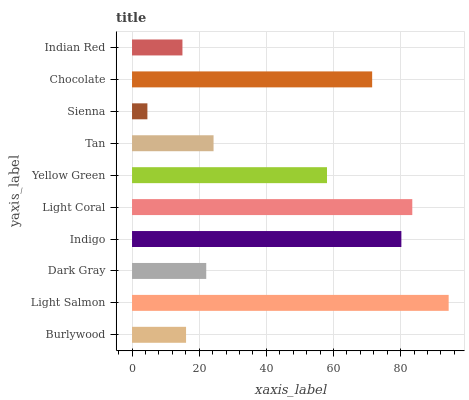Is Sienna the minimum?
Answer yes or no. Yes. Is Light Salmon the maximum?
Answer yes or no. Yes. Is Dark Gray the minimum?
Answer yes or no. No. Is Dark Gray the maximum?
Answer yes or no. No. Is Light Salmon greater than Dark Gray?
Answer yes or no. Yes. Is Dark Gray less than Light Salmon?
Answer yes or no. Yes. Is Dark Gray greater than Light Salmon?
Answer yes or no. No. Is Light Salmon less than Dark Gray?
Answer yes or no. No. Is Yellow Green the high median?
Answer yes or no. Yes. Is Tan the low median?
Answer yes or no. Yes. Is Dark Gray the high median?
Answer yes or no. No. Is Light Coral the low median?
Answer yes or no. No. 